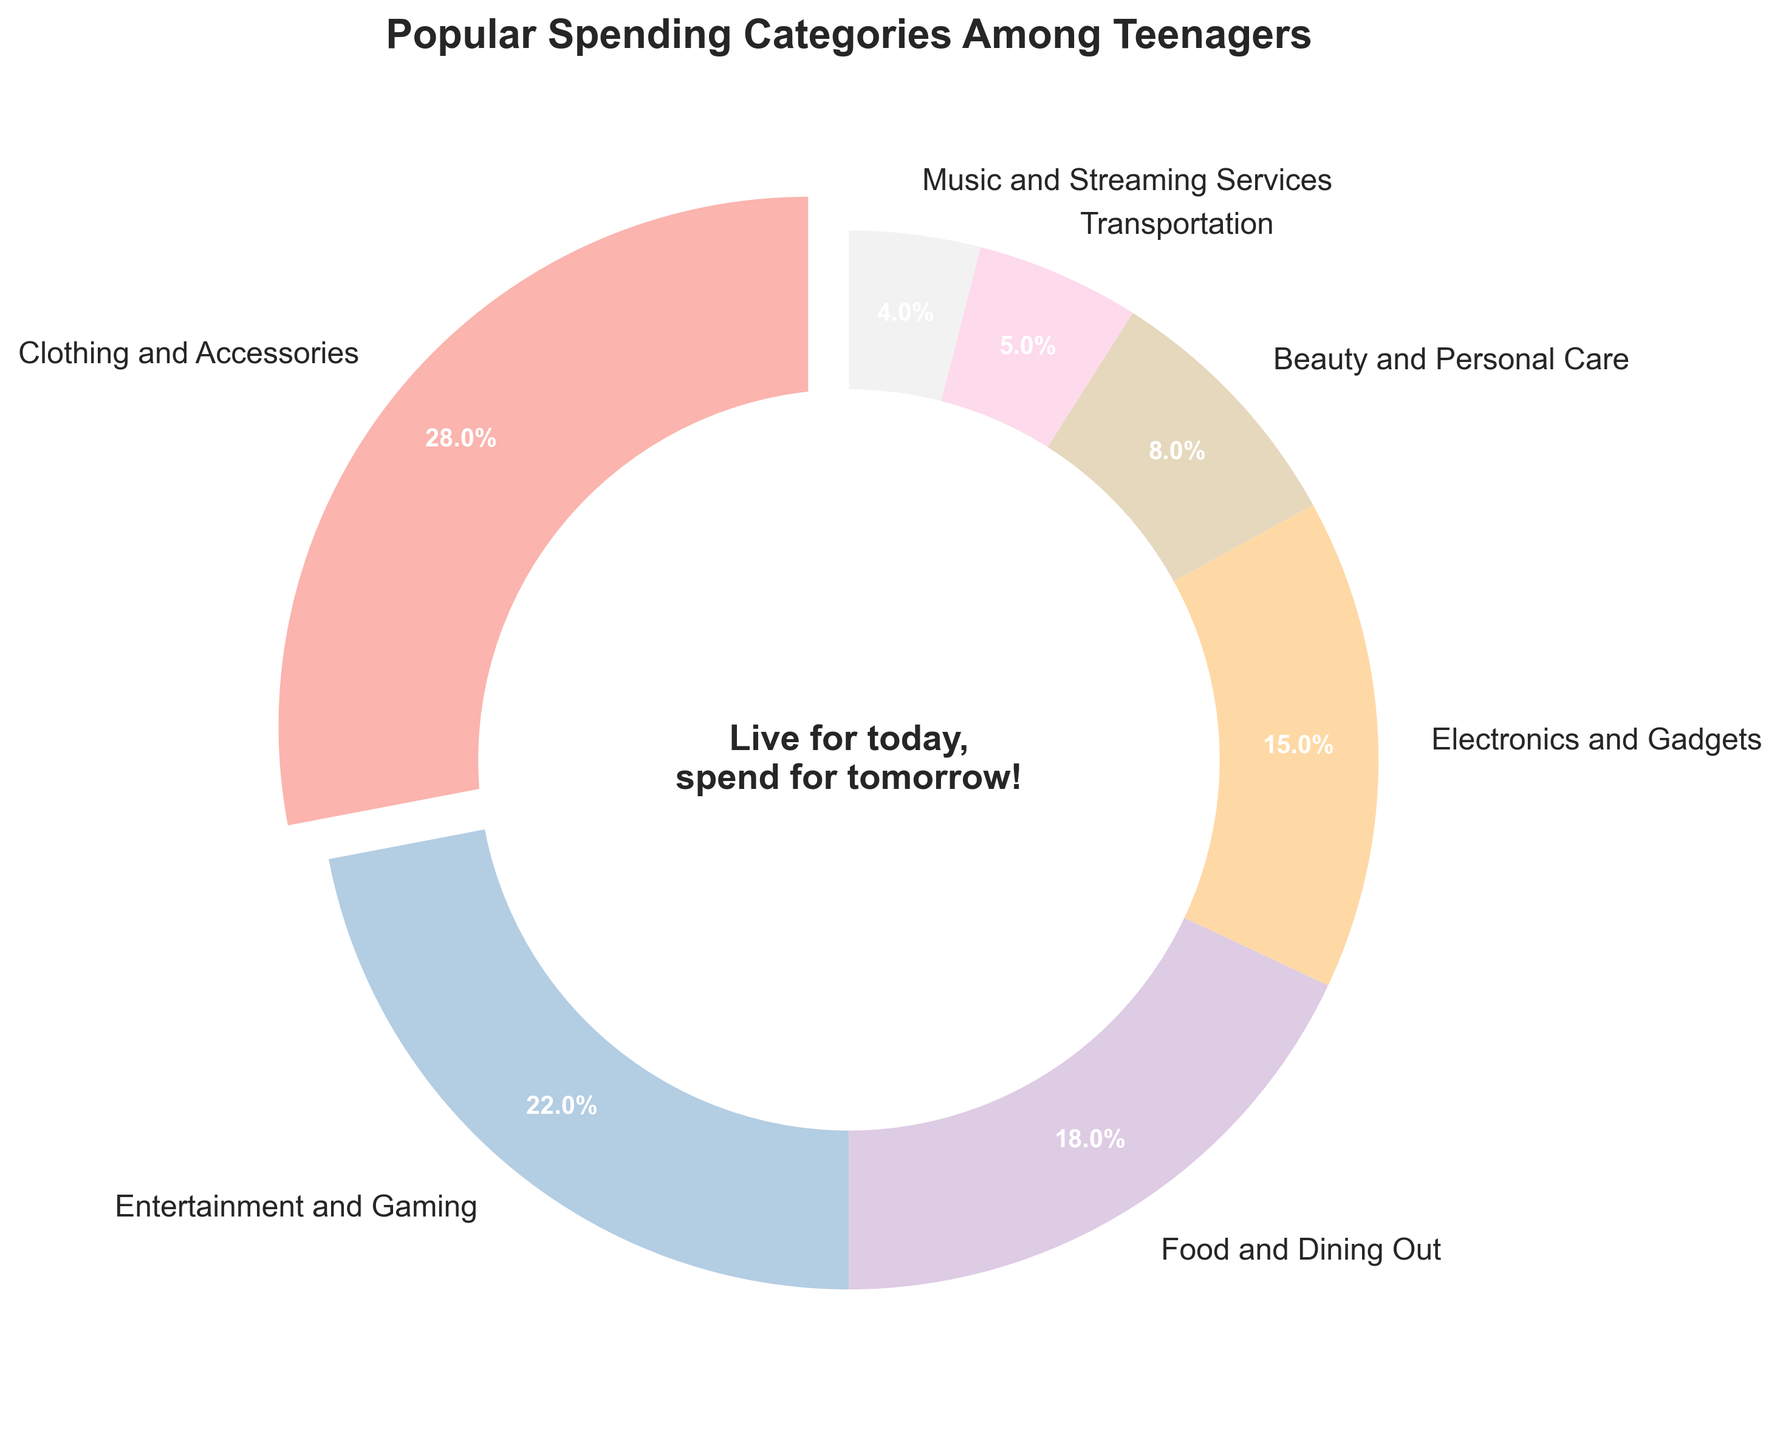What is the most popular spending category among teenagers? The category with the highest percentage in the pie chart represents the most popular spending category among teenagers. Clothing and Accessories makes up 28%, which is the highest percentage on the chart.
Answer: Clothing and Accessories What is the combined percentage of spending on Entertainment and Gaming and Food and Dining Out? To find the combined percentage, simply add the percentages of the two categories. Entertainment and Gaming is 22% and Food and Dining Out is 18%. 22% + 18% = 40%.
Answer: 40% Which category has the smallest percentage of spending? The category with the lowest percentage according to the pie chart is the one with the smallest slice. Music and Streaming Services has the smallest percentage at 4%.
Answer: Music and Streaming Services Is spending on Electronics and Gadgets greater than spending on Beauty and Personal Care? Compare the percentages for Electronics and Gadgets, which is 15%, and Beauty and Personal Care, which is 8%. 15% is greater than 8%, so yes, it is greater.
Answer: Yes What is the difference in spending percentage between Clothing and Accessories and Transportation? Subtract the percentage of Transportation (5%) from Clothing and Accessories (28%). 28% - 5% = 23%.
Answer: 23% How does the spending on Electronics and Gadgets compare to the spending on Entertainment and Gaming? Electronics and Gadgets account for 15% while Entertainment and Gaming account for 22%. Since 22% is greater than 15%, spending on Entertainment and Gaming is higher.
Answer: Entertainment and Gaming has higher spending If you combine spending on Beauty and Personal Care and Music and Streaming Services, do they equal spending on Food and Dining Out? Add the percentages of Beauty and Personal Care (8%) and Music and Streaming Services (4%). 8% + 4% = 12%. Compare this to Food and Dining Out, which is 18%. Since 12% is less than 18%, they do not equal.
Answer: No What is the visual style used in the pie chart? The pie chart uses light, pastel colors from the color palette and has a center circle with a motivational quote. This is indicated by the visual attributes of the chart and its elegant design and coloring.
Answer: Pastel/light colors and motivational quote Which slice of the pie chart is exploded, and why? The slice for the category with the highest spending percentage, which is Clothing and Accessories at 28%, is "exploded" or offset slightly to emphasize its importance.
Answer: Clothing and Accessories If spending on Transportation increased by 3 percentage points, would it surpass the spending on Beauty and Personal Care? If Transportation's current percentage (5%) increases by 3 percentage points, it becomes 8%. Since Beauty and Personal Care also has 8%, they would be equal, not surpass.
Answer: No 